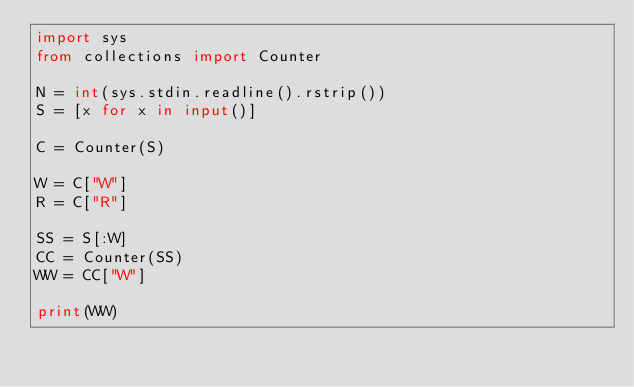<code> <loc_0><loc_0><loc_500><loc_500><_Python_>import sys
from collections import Counter

N = int(sys.stdin.readline().rstrip())
S = [x for x in input()]

C = Counter(S)

W = C["W"]
R = C["R"]

SS = S[:W]
CC = Counter(SS)
WW = CC["W"]

print(WW)
</code> 